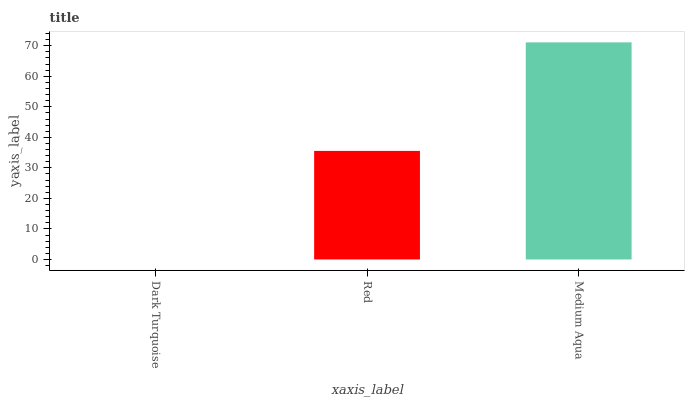Is Dark Turquoise the minimum?
Answer yes or no. Yes. Is Medium Aqua the maximum?
Answer yes or no. Yes. Is Red the minimum?
Answer yes or no. No. Is Red the maximum?
Answer yes or no. No. Is Red greater than Dark Turquoise?
Answer yes or no. Yes. Is Dark Turquoise less than Red?
Answer yes or no. Yes. Is Dark Turquoise greater than Red?
Answer yes or no. No. Is Red less than Dark Turquoise?
Answer yes or no. No. Is Red the high median?
Answer yes or no. Yes. Is Red the low median?
Answer yes or no. Yes. Is Dark Turquoise the high median?
Answer yes or no. No. Is Dark Turquoise the low median?
Answer yes or no. No. 